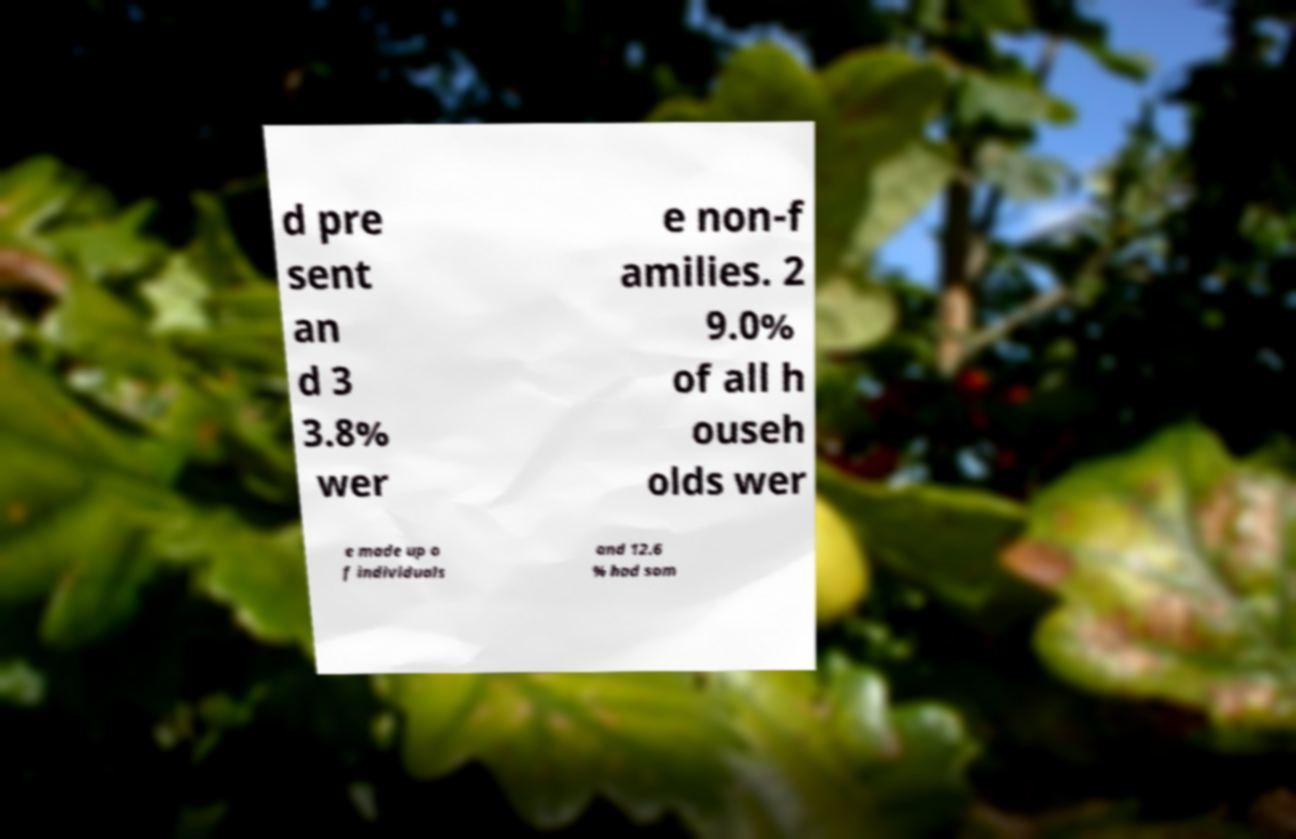Could you assist in decoding the text presented in this image and type it out clearly? d pre sent an d 3 3.8% wer e non-f amilies. 2 9.0% of all h ouseh olds wer e made up o f individuals and 12.6 % had som 